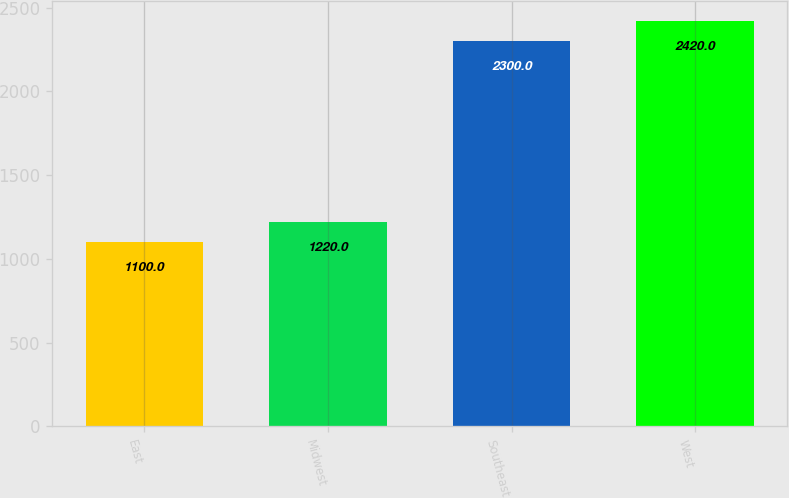Convert chart. <chart><loc_0><loc_0><loc_500><loc_500><bar_chart><fcel>East<fcel>Midwest<fcel>Southeast<fcel>West<nl><fcel>1100<fcel>1220<fcel>2300<fcel>2420<nl></chart> 